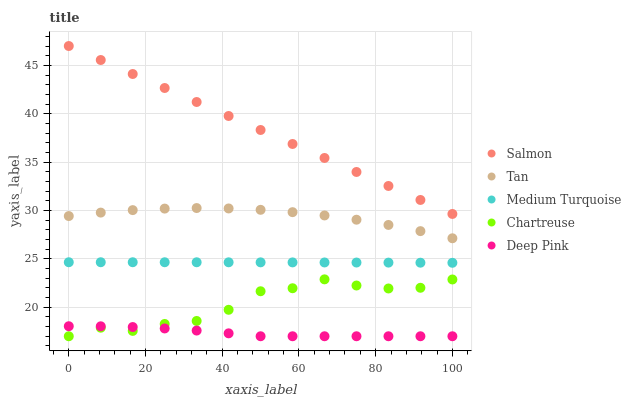Does Deep Pink have the minimum area under the curve?
Answer yes or no. Yes. Does Salmon have the maximum area under the curve?
Answer yes or no. Yes. Does Salmon have the minimum area under the curve?
Answer yes or no. No. Does Deep Pink have the maximum area under the curve?
Answer yes or no. No. Is Salmon the smoothest?
Answer yes or no. Yes. Is Chartreuse the roughest?
Answer yes or no. Yes. Is Deep Pink the smoothest?
Answer yes or no. No. Is Deep Pink the roughest?
Answer yes or no. No. Does Deep Pink have the lowest value?
Answer yes or no. Yes. Does Salmon have the lowest value?
Answer yes or no. No. Does Salmon have the highest value?
Answer yes or no. Yes. Does Deep Pink have the highest value?
Answer yes or no. No. Is Chartreuse less than Tan?
Answer yes or no. Yes. Is Salmon greater than Deep Pink?
Answer yes or no. Yes. Does Chartreuse intersect Deep Pink?
Answer yes or no. Yes. Is Chartreuse less than Deep Pink?
Answer yes or no. No. Is Chartreuse greater than Deep Pink?
Answer yes or no. No. Does Chartreuse intersect Tan?
Answer yes or no. No. 